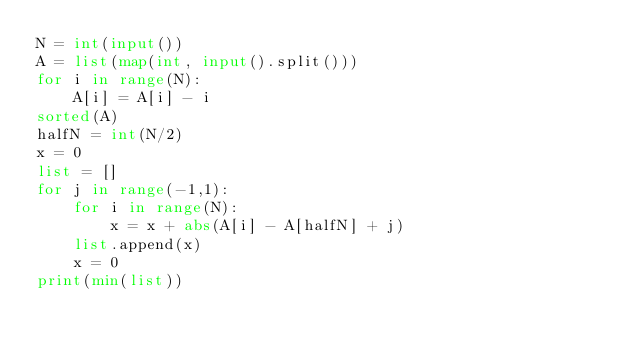<code> <loc_0><loc_0><loc_500><loc_500><_Python_>N = int(input())
A = list(map(int, input().split()))
for i in range(N):
    A[i] = A[i] - i
sorted(A)
halfN = int(N/2)
x = 0
list = []
for j in range(-1,1):
    for i in range(N):
        x = x + abs(A[i] - A[halfN] + j)
    list.append(x)
    x = 0
print(min(list))
</code> 